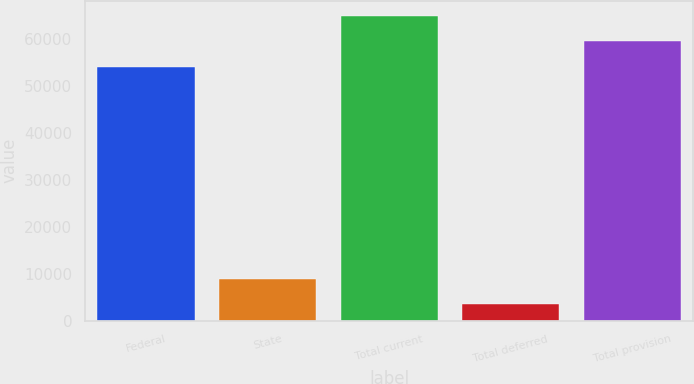Convert chart to OTSL. <chart><loc_0><loc_0><loc_500><loc_500><bar_chart><fcel>Federal<fcel>State<fcel>Total current<fcel>Total deferred<fcel>Total provision<nl><fcel>54022<fcel>8962.4<fcel>64886.8<fcel>3530<fcel>59454.4<nl></chart> 